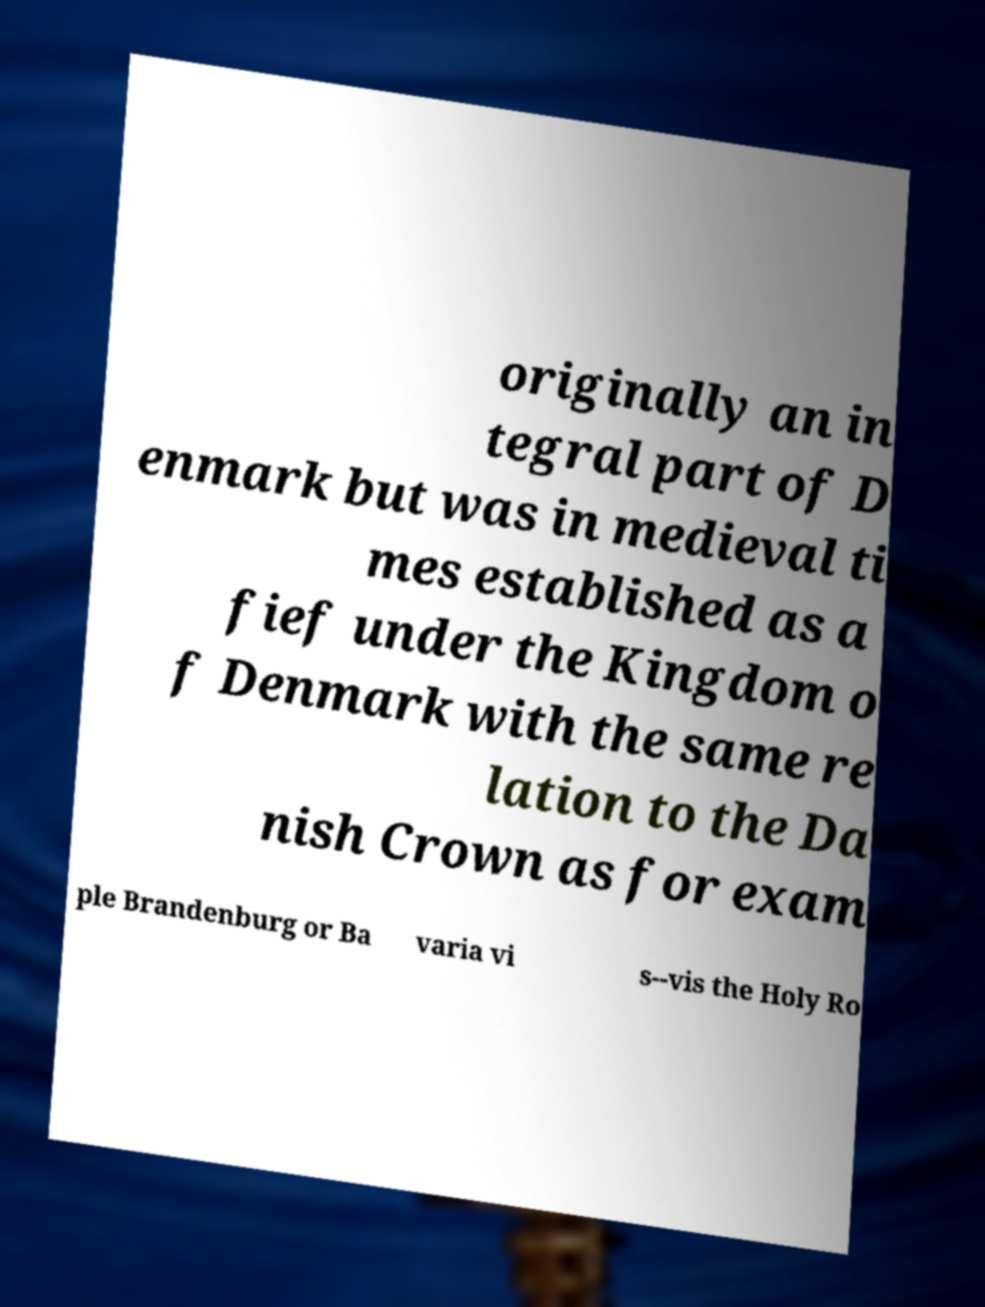For documentation purposes, I need the text within this image transcribed. Could you provide that? originally an in tegral part of D enmark but was in medieval ti mes established as a fief under the Kingdom o f Denmark with the same re lation to the Da nish Crown as for exam ple Brandenburg or Ba varia vi s--vis the Holy Ro 